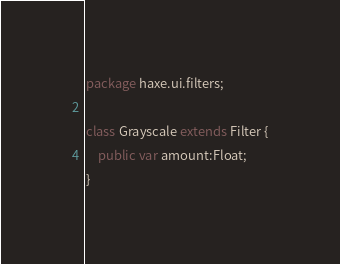<code> <loc_0><loc_0><loc_500><loc_500><_Haxe_>package haxe.ui.filters;

class Grayscale extends Filter {
    public var amount:Float;
}</code> 